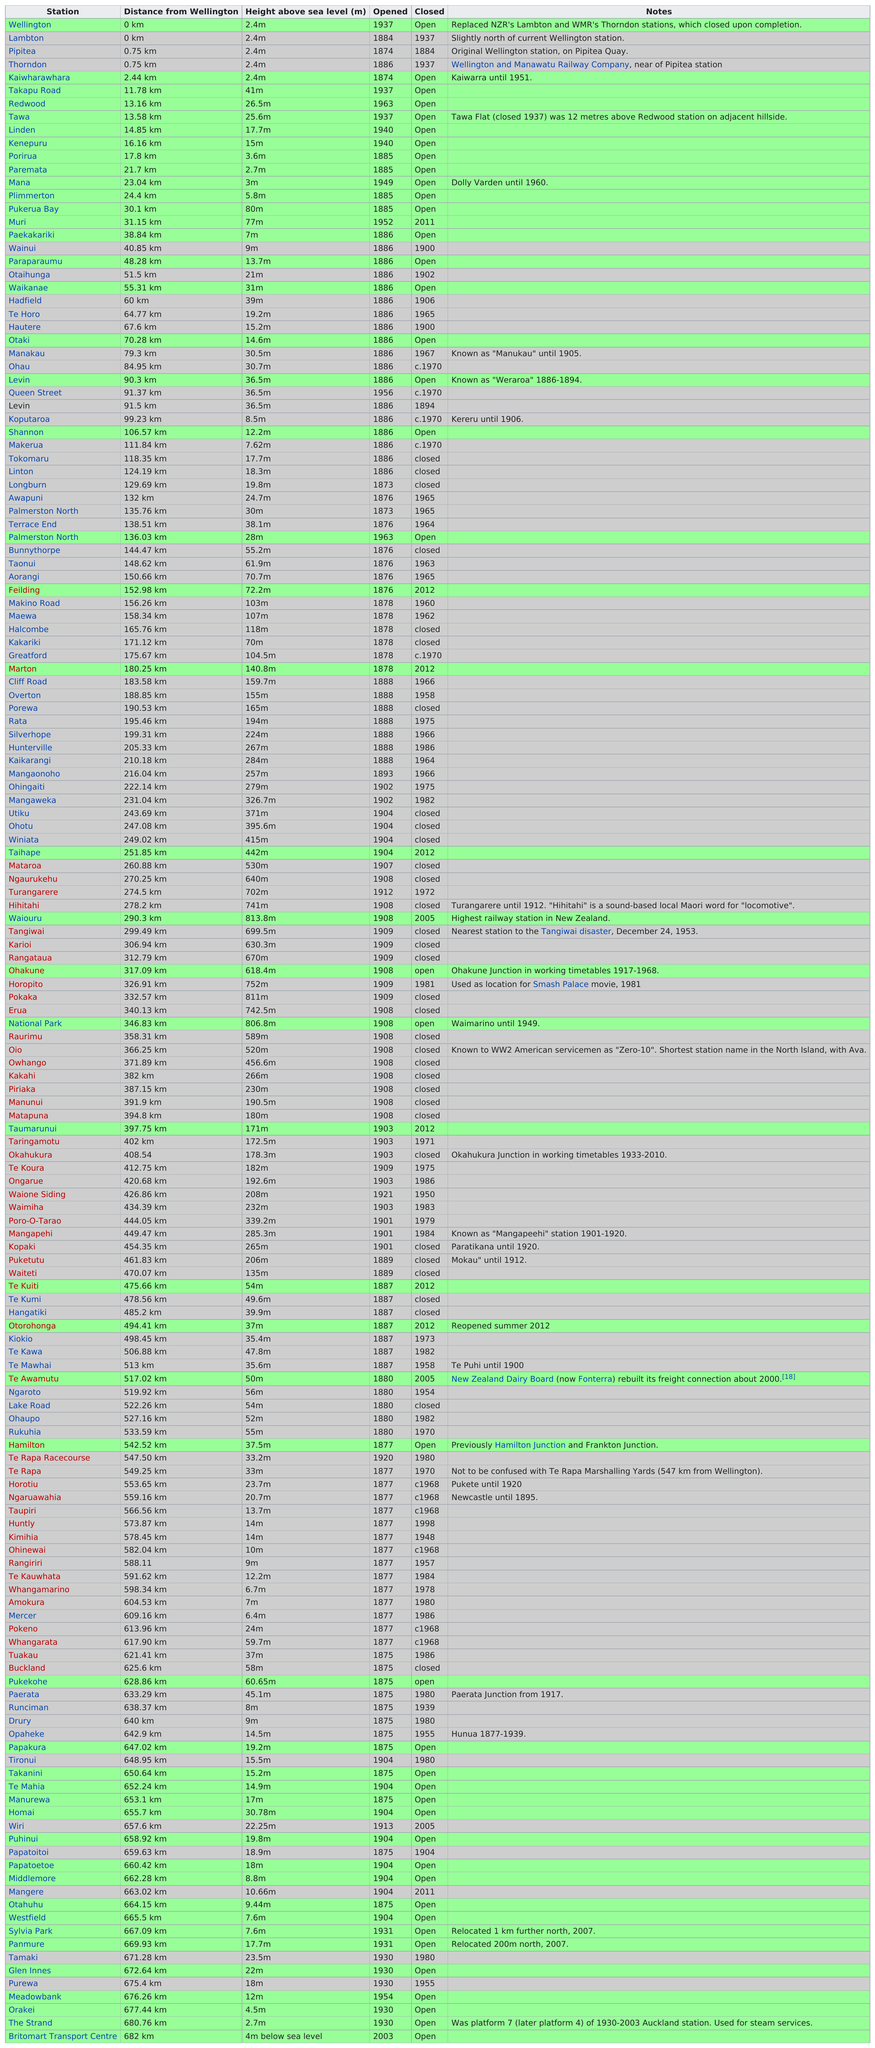Identify some key points in this picture. The Takapu Road station is 38.6 meters higher than the Wellington station. 